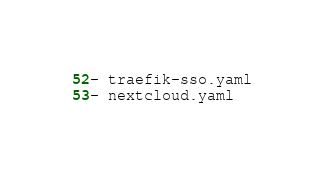Convert code to text. <code><loc_0><loc_0><loc_500><loc_500><_YAML_>- traefik-sso.yaml
- nextcloud.yaml
</code> 